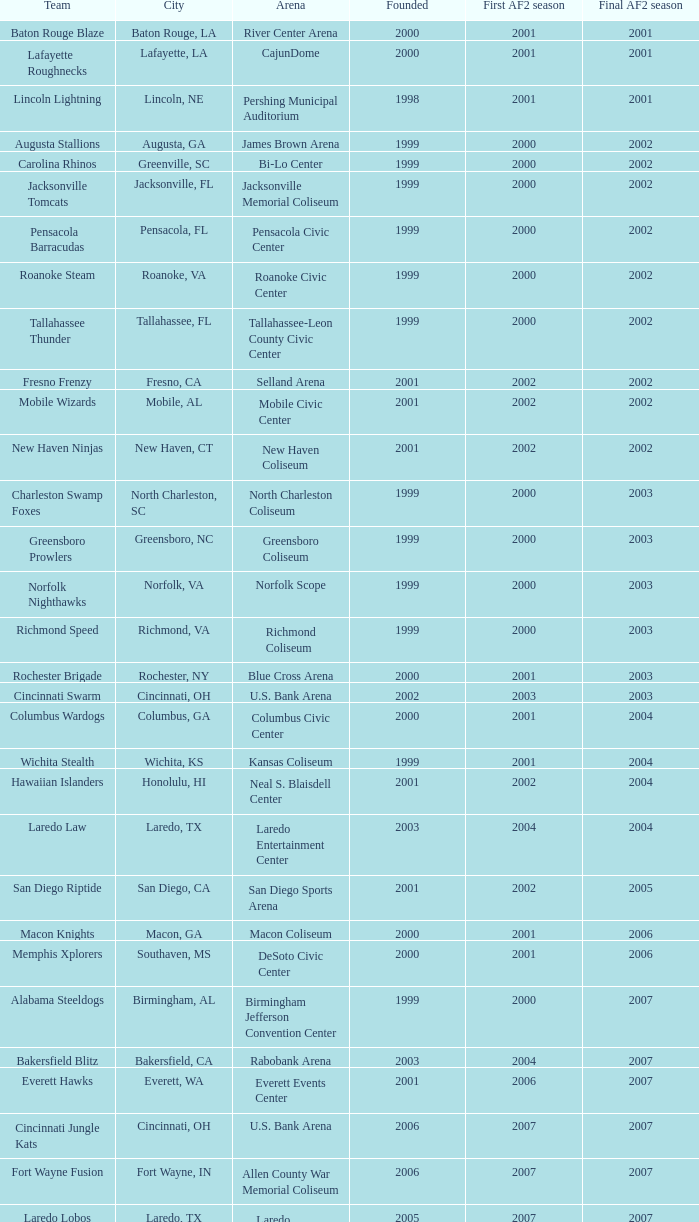Give me the full table as a dictionary. {'header': ['Team', 'City', 'Arena', 'Founded', 'First AF2 season', 'Final AF2 season'], 'rows': [['Baton Rouge Blaze', 'Baton Rouge, LA', 'River Center Arena', '2000', '2001', '2001'], ['Lafayette Roughnecks', 'Lafayette, LA', 'CajunDome', '2000', '2001', '2001'], ['Lincoln Lightning', 'Lincoln, NE', 'Pershing Municipal Auditorium', '1998', '2001', '2001'], ['Augusta Stallions', 'Augusta, GA', 'James Brown Arena', '1999', '2000', '2002'], ['Carolina Rhinos', 'Greenville, SC', 'Bi-Lo Center', '1999', '2000', '2002'], ['Jacksonville Tomcats', 'Jacksonville, FL', 'Jacksonville Memorial Coliseum', '1999', '2000', '2002'], ['Pensacola Barracudas', 'Pensacola, FL', 'Pensacola Civic Center', '1999', '2000', '2002'], ['Roanoke Steam', 'Roanoke, VA', 'Roanoke Civic Center', '1999', '2000', '2002'], ['Tallahassee Thunder', 'Tallahassee, FL', 'Tallahassee-Leon County Civic Center', '1999', '2000', '2002'], ['Fresno Frenzy', 'Fresno, CA', 'Selland Arena', '2001', '2002', '2002'], ['Mobile Wizards', 'Mobile, AL', 'Mobile Civic Center', '2001', '2002', '2002'], ['New Haven Ninjas', 'New Haven, CT', 'New Haven Coliseum', '2001', '2002', '2002'], ['Charleston Swamp Foxes', 'North Charleston, SC', 'North Charleston Coliseum', '1999', '2000', '2003'], ['Greensboro Prowlers', 'Greensboro, NC', 'Greensboro Coliseum', '1999', '2000', '2003'], ['Norfolk Nighthawks', 'Norfolk, VA', 'Norfolk Scope', '1999', '2000', '2003'], ['Richmond Speed', 'Richmond, VA', 'Richmond Coliseum', '1999', '2000', '2003'], ['Rochester Brigade', 'Rochester, NY', 'Blue Cross Arena', '2000', '2001', '2003'], ['Cincinnati Swarm', 'Cincinnati, OH', 'U.S. Bank Arena', '2002', '2003', '2003'], ['Columbus Wardogs', 'Columbus, GA', 'Columbus Civic Center', '2000', '2001', '2004'], ['Wichita Stealth', 'Wichita, KS', 'Kansas Coliseum', '1999', '2001', '2004'], ['Hawaiian Islanders', 'Honolulu, HI', 'Neal S. Blaisdell Center', '2001', '2002', '2004'], ['Laredo Law', 'Laredo, TX', 'Laredo Entertainment Center', '2003', '2004', '2004'], ['San Diego Riptide', 'San Diego, CA', 'San Diego Sports Arena', '2001', '2002', '2005'], ['Macon Knights', 'Macon, GA', 'Macon Coliseum', '2000', '2001', '2006'], ['Memphis Xplorers', 'Southaven, MS', 'DeSoto Civic Center', '2000', '2001', '2006'], ['Alabama Steeldogs', 'Birmingham, AL', 'Birmingham Jefferson Convention Center', '1999', '2000', '2007'], ['Bakersfield Blitz', 'Bakersfield, CA', 'Rabobank Arena', '2003', '2004', '2007'], ['Everett Hawks', 'Everett, WA', 'Everett Events Center', '2001', '2006', '2007'], ['Cincinnati Jungle Kats', 'Cincinnati, OH', 'U.S. Bank Arena', '2006', '2007', '2007'], ['Fort Wayne Fusion', 'Fort Wayne, IN', 'Allen County War Memorial Coliseum', '2006', '2007', '2007'], ['Laredo Lobos', 'Laredo, TX', 'Laredo Entertainment Center', '2005', '2007', '2007'], ['Louisville Fire', 'Louisville, KY', 'Freedom Hall', '2000', '2001', '2008'], ['Lubbock Renegades', 'Lubbock, TX', 'City Bank Coliseum', '2006', '2007', '2008'], ['Texas Copperheads', 'Cypress, TX', 'Richard E. Berry Educational Support Center', '2005', '2007', '2008'], ['Austin Wranglers', 'Austin, TX', 'Frank Erwin Center', '2003', '2008', '2008'], ['Daytona Beach ThunderBirds', 'Daytona Beach, FL', 'Ocean Center', '2005', '2008', '2008'], ['Mahoning Valley Thunder', 'Youngstown, OH', 'Covelli Centre', '2007', '2007', '2009'], ['Arkansas Twisters', 'North Little Rock, Arkansas', 'Verizon Arena', '1999', '2000', '2009'], ['Central Valley Coyotes', 'Fresno, California', 'Selland Arena', '2001', '2002', '2009'], ['Kentucky Horsemen', 'Lexington, Kentucky', 'Rupp Arena', '2002', '2008', '2009'], ['Tri-Cities Fever', 'Kennewick, Washington', 'Toyota Center', '2004', '2007', '2009']]} What is the average founded number for the baton rouge blaze team? 2000.0. 